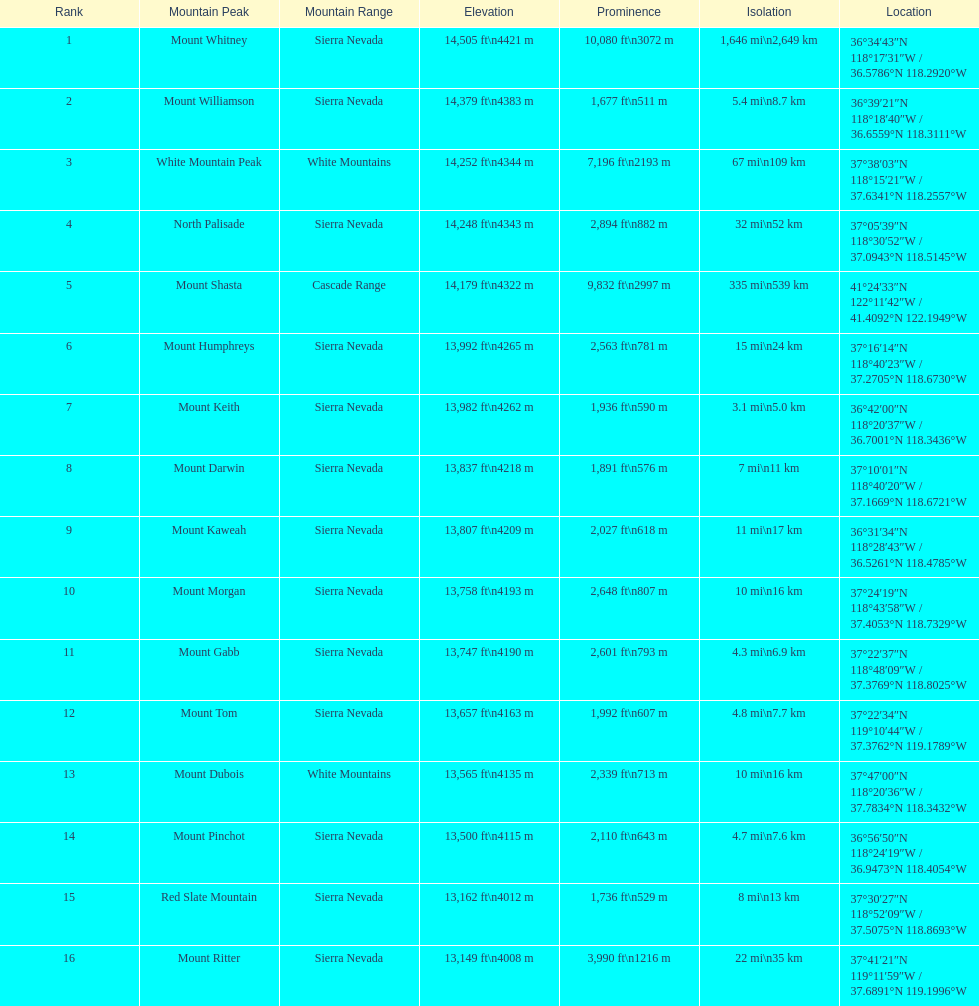Which mountain summit has the lowest isolation? Mount Keith. 